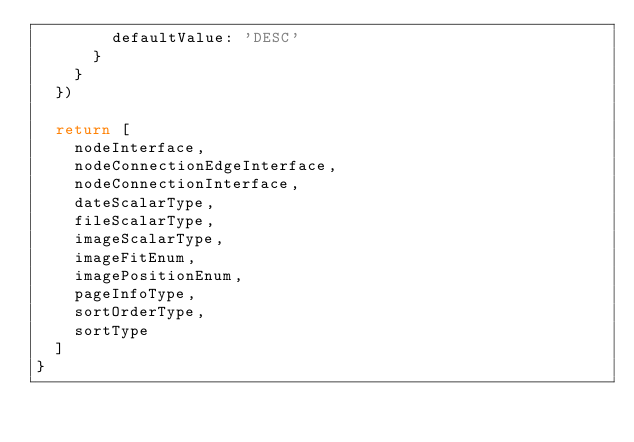<code> <loc_0><loc_0><loc_500><loc_500><_JavaScript_>        defaultValue: 'DESC'
      }
    }
  })

  return [
    nodeInterface,
    nodeConnectionEdgeInterface,
    nodeConnectionInterface,
    dateScalarType,
    fileScalarType,
    imageScalarType,
    imageFitEnum,
    imagePositionEnum,
    pageInfoType,
    sortOrderType,
    sortType
  ]
}
</code> 